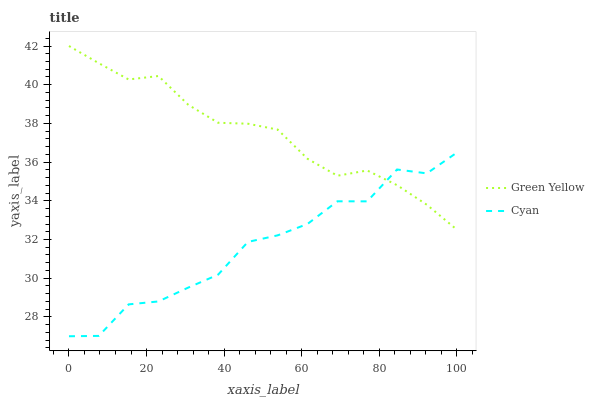Does Cyan have the minimum area under the curve?
Answer yes or no. Yes. Does Green Yellow have the maximum area under the curve?
Answer yes or no. Yes. Does Green Yellow have the minimum area under the curve?
Answer yes or no. No. Is Green Yellow the smoothest?
Answer yes or no. Yes. Is Cyan the roughest?
Answer yes or no. Yes. Is Green Yellow the roughest?
Answer yes or no. No. Does Cyan have the lowest value?
Answer yes or no. Yes. Does Green Yellow have the lowest value?
Answer yes or no. No. Does Green Yellow have the highest value?
Answer yes or no. Yes. Does Cyan intersect Green Yellow?
Answer yes or no. Yes. Is Cyan less than Green Yellow?
Answer yes or no. No. Is Cyan greater than Green Yellow?
Answer yes or no. No. 